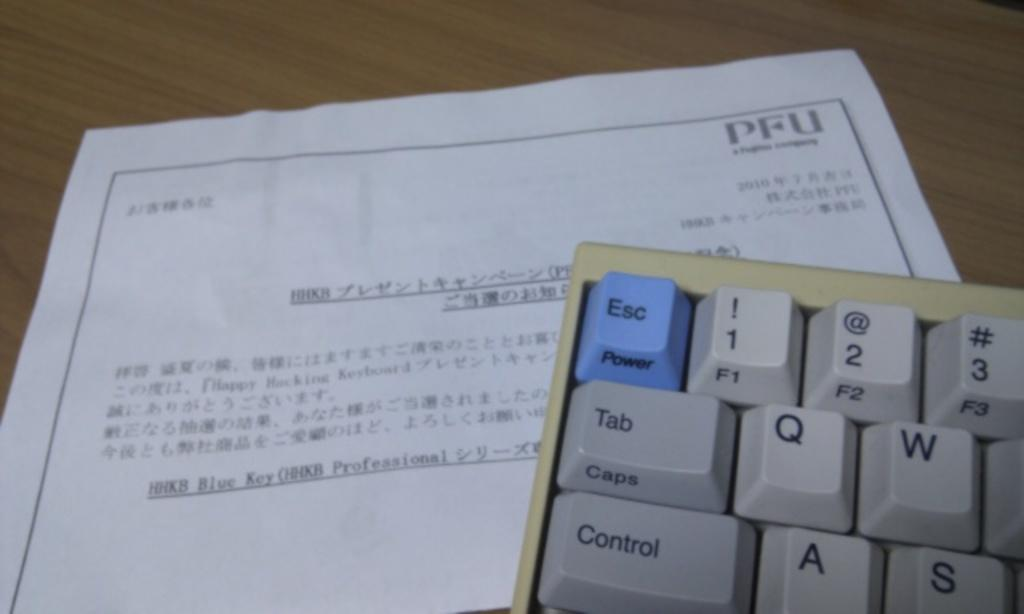Provide a one-sentence caption for the provided image. The tope left ten keys of a keyboard rest on a sheet of paper that has chinese writing. 